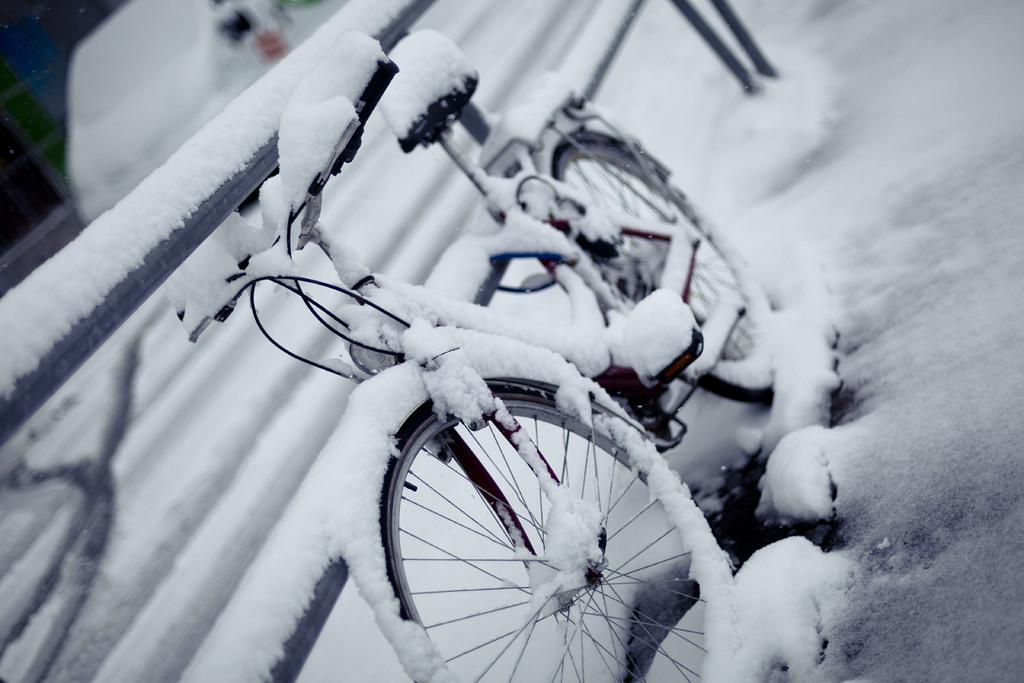What is the main object in the image? There is a bicycle in the image. What is the weather like in the image? There is snow in the image, indicating a cold or wintery setting. What is located beside the bicycle? There is a fence beside the bicycle. What other mode of transportation is present in the image? There is a vehicle in the image. Can you describe any other objects in the image? There are some objects in the image, but their specific nature is not mentioned in the provided facts. Can you see the bird's wing in the image? There is no bird or wing present in the image. What is the person on the bicycle smiling about in the image? There is no person or indication of a smile in the image. 